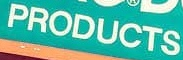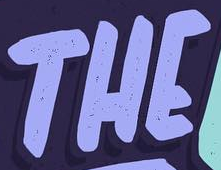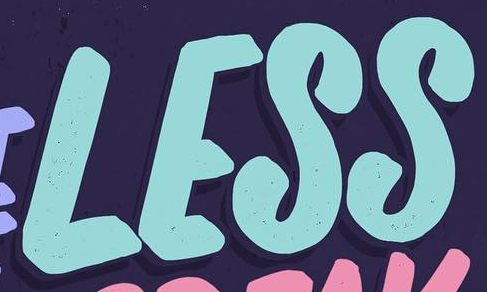Identify the words shown in these images in order, separated by a semicolon. PRODUCTS; THE; LESS 